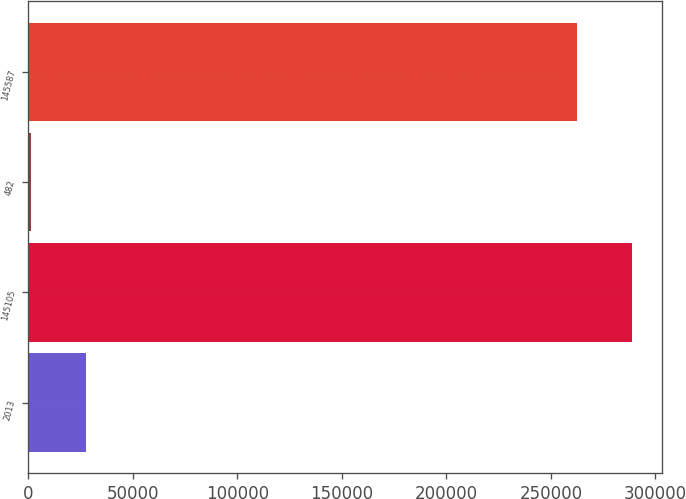<chart> <loc_0><loc_0><loc_500><loc_500><bar_chart><fcel>2013<fcel>145105<fcel>482<fcel>145587<nl><fcel>27590<fcel>288860<fcel>1330<fcel>262600<nl></chart> 